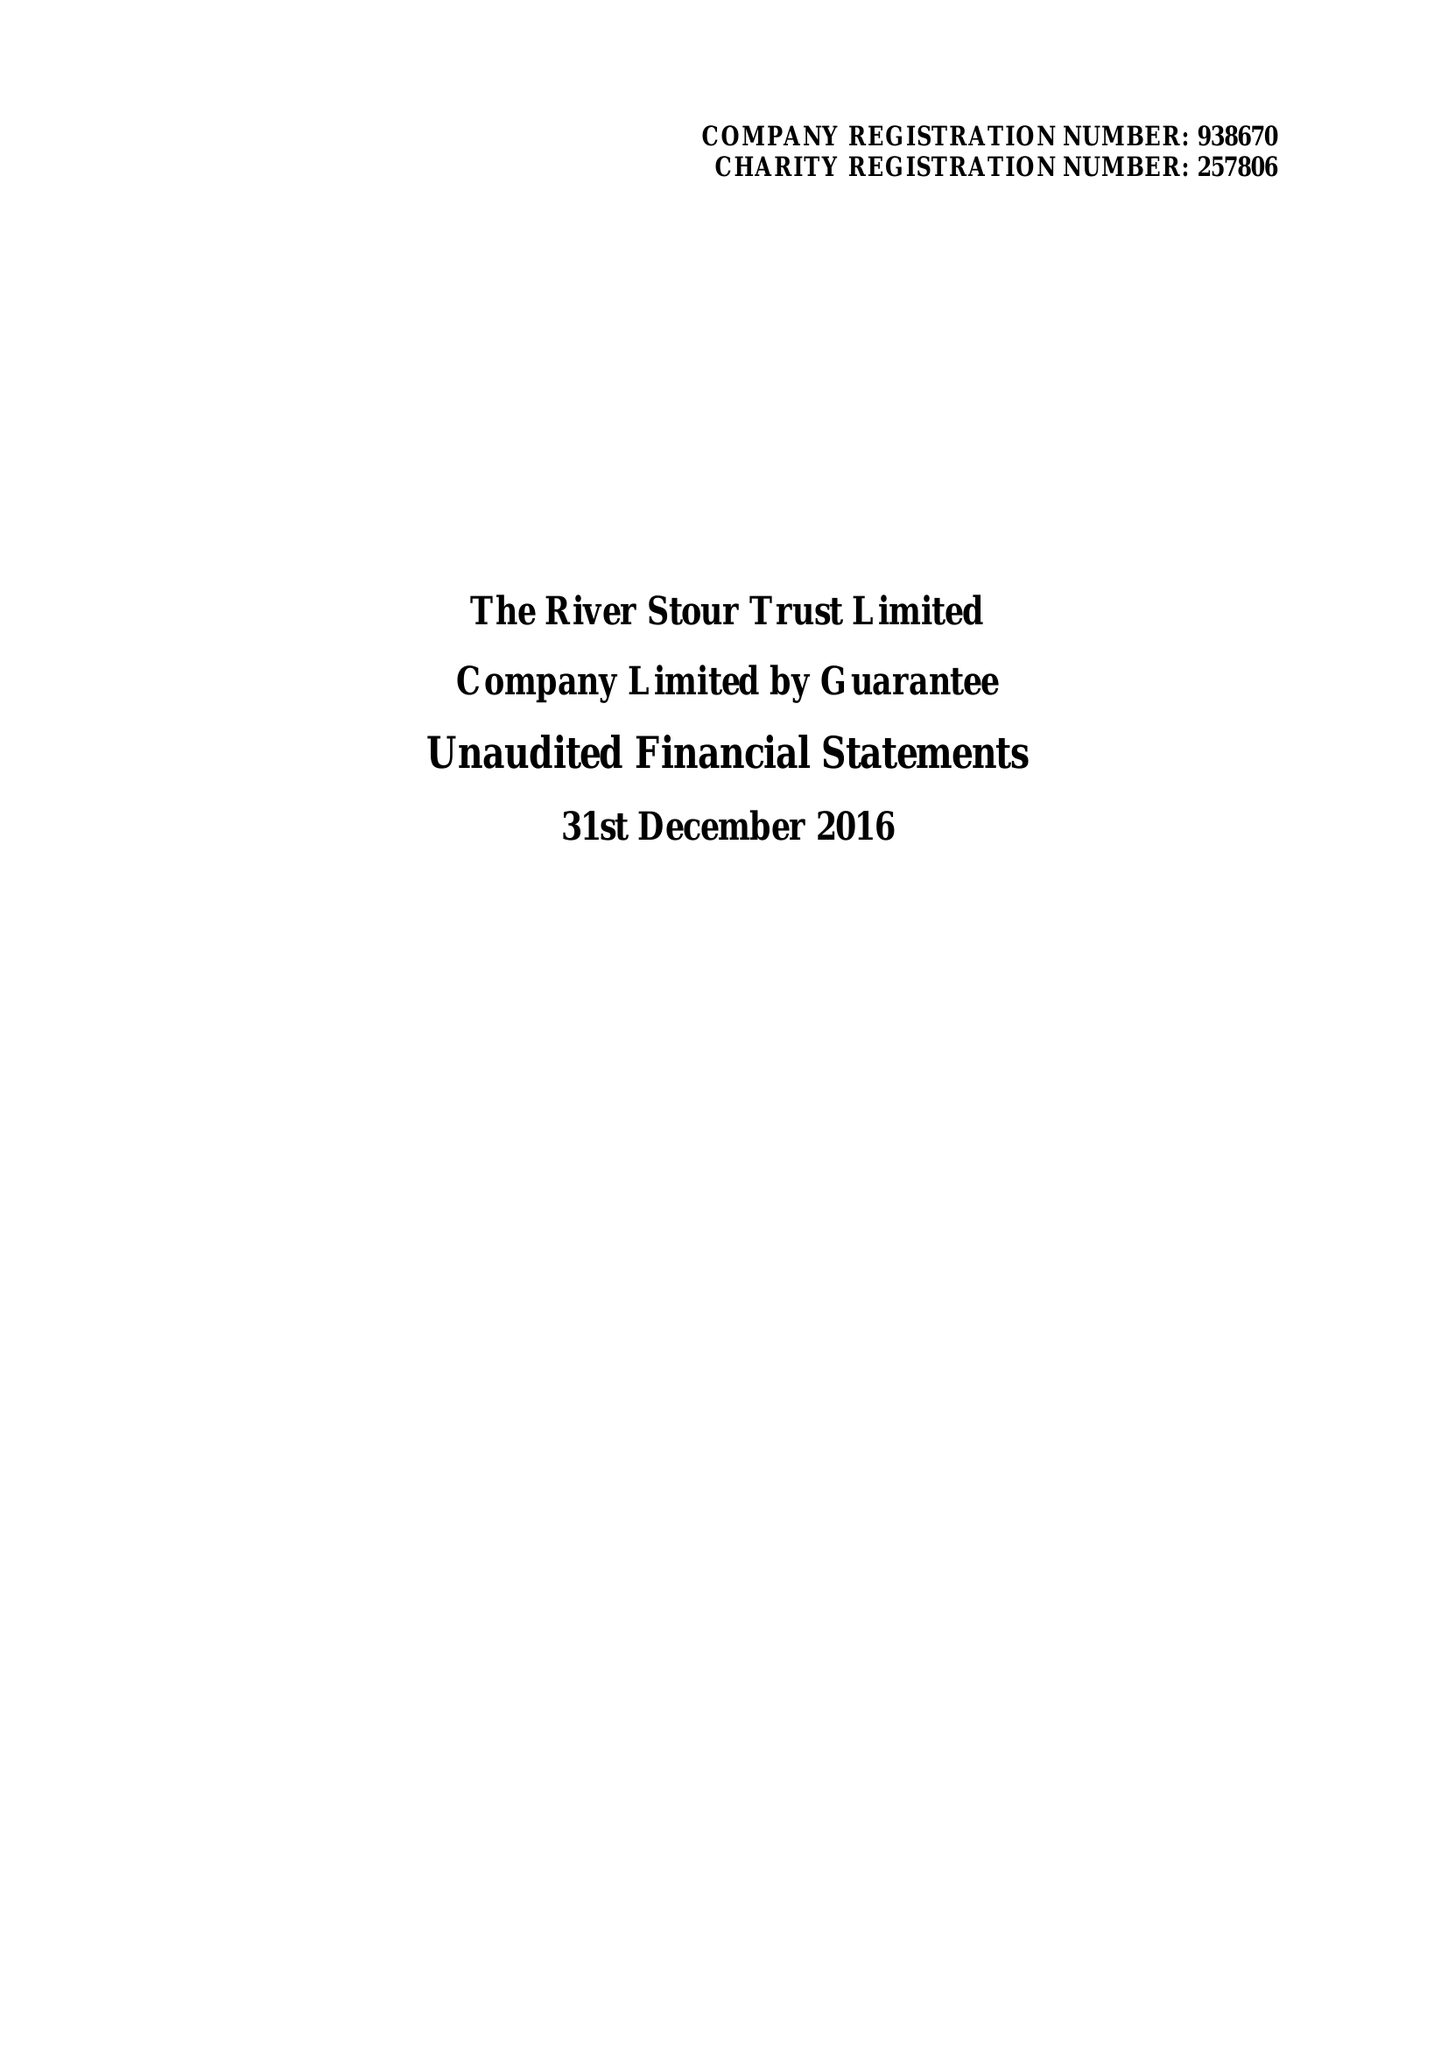What is the value for the income_annually_in_british_pounds?
Answer the question using a single word or phrase. 121316.00 